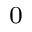Convert formula to latex. <formula><loc_0><loc_0><loc_500><loc_500>_ { 0 }</formula> 